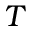<formula> <loc_0><loc_0><loc_500><loc_500>T</formula> 